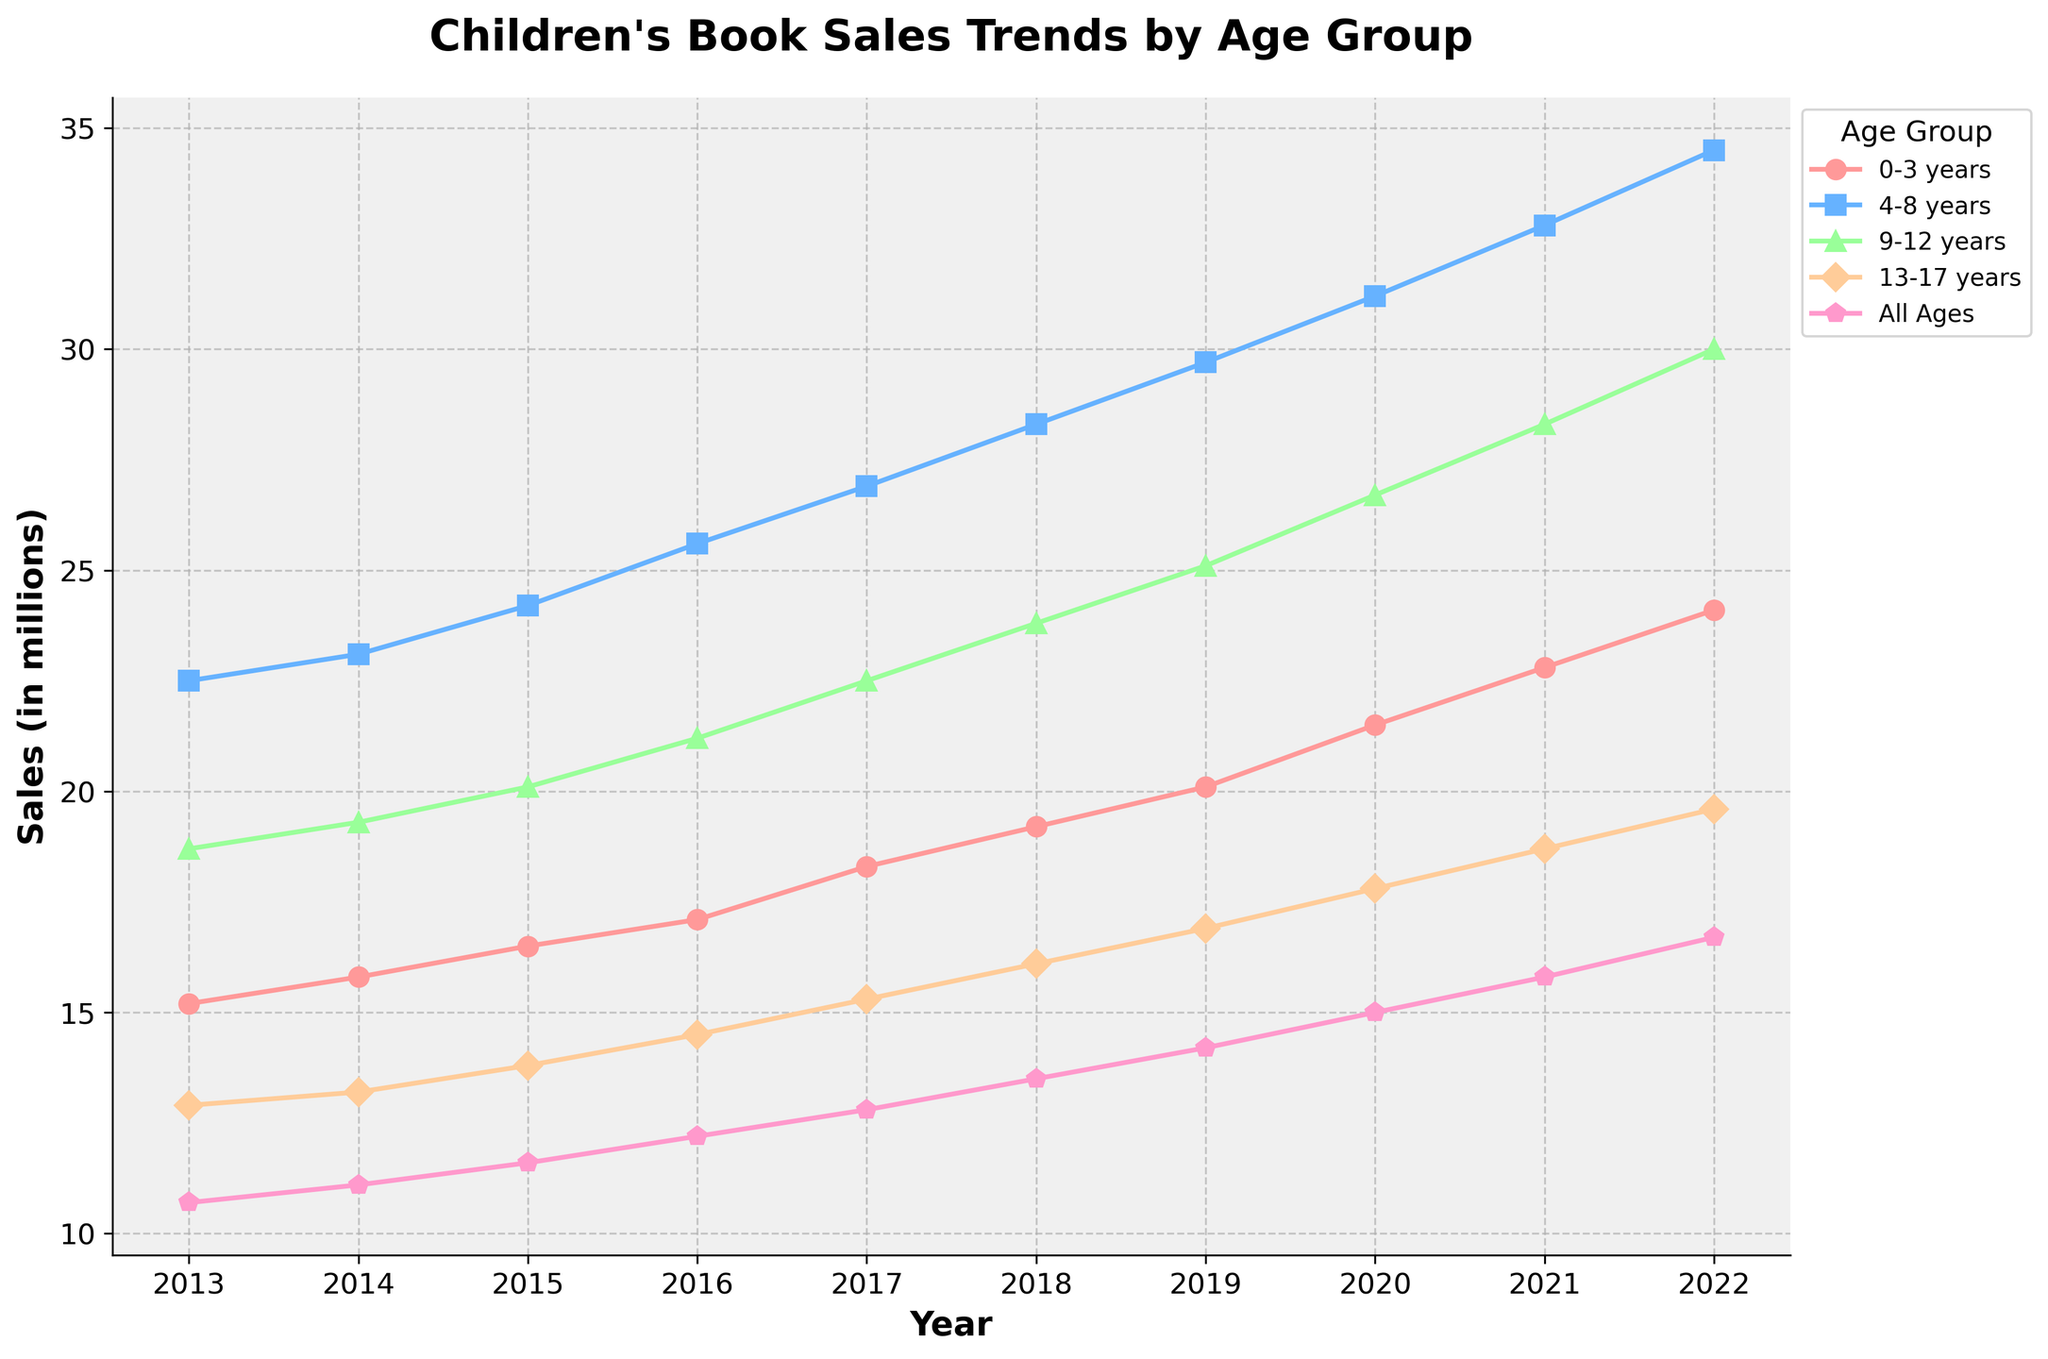What is the trend in book sales for the "0-3 years" age group from 2013 to 2022? Looking at the line for the "0-3 years" age group, there is a consistent upward trend from 2013 (15.2 million) to 2022 (24.1 million).
Answer: Increasing trend Which age group had the highest sales in 2022? By comparing the endpoints of all lines in 2022, the "4-8 years" age group has the highest sales with 34.5 million.
Answer: 4-8 years What is the difference in book sales between the "9-12 years" and "13-17 years" groups in 2015? In 2015, the sales for "9-12 years" is 20.1 million, and for "13-17 years" it is 13.8 million. Subtracting these, 20.1 - 13.8 = 6.3 million.
Answer: 6.3 million Which age group's book sales increased the most from 2013 to 2022? By calculating the difference (2022 sales - 2013 sales) for each group: 0-3 years increased by 8.9 million, 4-8 years by 12 million, 9-12 years by 11.3 million, 13-17 years by 6.7 million, and All Ages by 6 million. The group "4-8 years" had the largest increase.
Answer: 4-8 years In which year did the "0-3 years" age group surpass 20 million in sales? Observing the "0-3 years" line, it surpasses 20 million in the year 2019.
Answer: 2019 Which age group had the smallest increment in sales from 2019 to 2022? By comparing the difference (2022 sales - 2019 sales) for each group: 0-3 years increased by 4 million, 4-8 years by 4.8 million, 9-12 years by 4.9 million, 13-17 years by 2.7 million, and All Ages by 2.5 million. The "All Ages" group had the smallest increment.
Answer: All Ages If the trend continues, which age group’s sales are likely to exceed 30 million first after 2022? The "4-8 years" group already exceeded 30 million in 2021, and "9-12 years" reached 30 million in 2022 and might keep growing. Thus, "9-12 years" would likely continue to stay above 30 million.
Answer: 9-12 years Compare the sales of "4-8 years" and "All Ages" groups in 2017. Which one is higher and by how much? In 2017, sales for "4-8 years" is 26.9 million and for "All Ages" is 12.8 million. The difference is 26.9 - 12.8 = 14.1 million, with "4-8 years" having the higher sales.
Answer: 4-8 years by 14.1 million How did the sales for the "13-17 years" age group change from 2013 to 2018? The sales in 2013 were 12.9 million and increased to 16.1 million in 2018. The increase is 16.1 - 12.9 = 3.2 million.
Answer: Increased by 3.2 million 